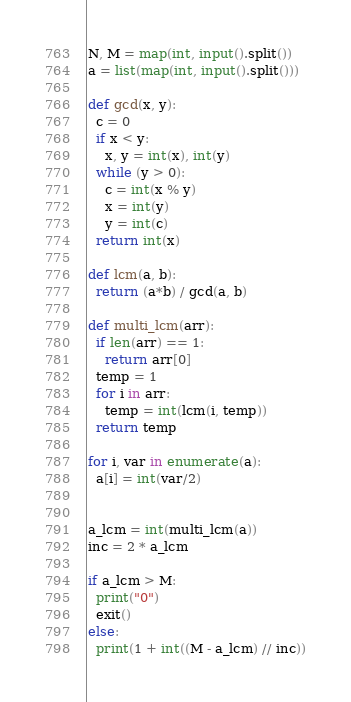Convert code to text. <code><loc_0><loc_0><loc_500><loc_500><_Python_>N, M = map(int, input().split())
a = list(map(int, input().split()))

def gcd(x, y):
  c = 0
  if x < y:
    x, y = int(x), int(y)
  while (y > 0):
    c = int(x % y)
    x = int(y)
    y = int(c)
  return int(x)

def lcm(a, b):
  return (a*b) / gcd(a, b)

def multi_lcm(arr):
  if len(arr) == 1:
    return arr[0]
  temp = 1
  for i in arr:
    temp = int(lcm(i, temp))
  return temp

for i, var in enumerate(a):
  a[i] = int(var/2)


a_lcm = int(multi_lcm(a))
inc = 2 * a_lcm

if a_lcm > M:
  print("0")
  exit()
else:
  print(1 + int((M - a_lcm) // inc))

</code> 